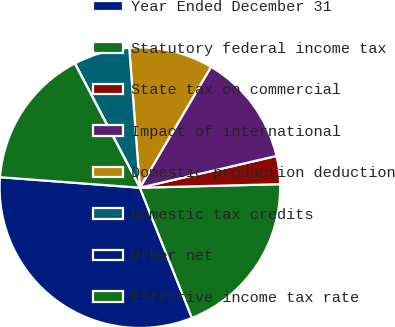Convert chart. <chart><loc_0><loc_0><loc_500><loc_500><pie_chart><fcel>Year Ended December 31<fcel>Statutory federal income tax<fcel>State tax on commercial<fcel>Impact of international<fcel>Domestic production deduction<fcel>Domestic tax credits<fcel>Other net<fcel>Effective income tax rate<nl><fcel>32.25%<fcel>19.35%<fcel>3.23%<fcel>12.9%<fcel>9.68%<fcel>6.46%<fcel>0.01%<fcel>16.13%<nl></chart> 